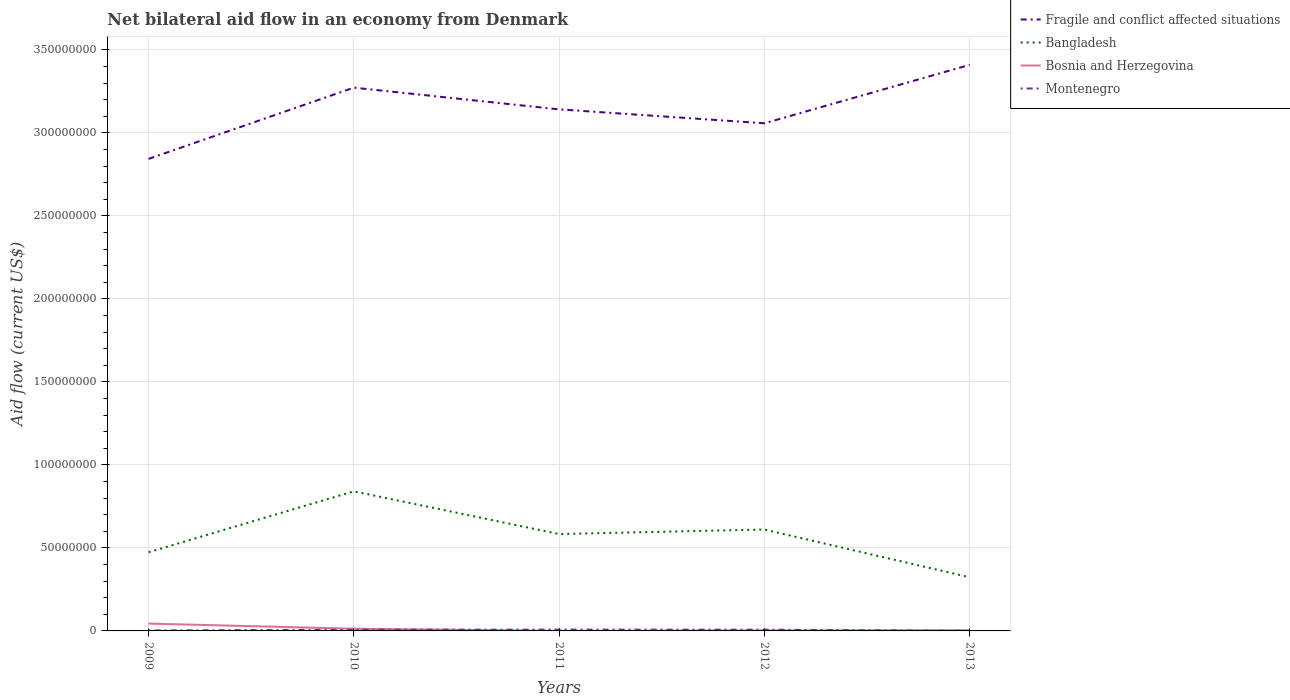How many different coloured lines are there?
Give a very brief answer. 4. Across all years, what is the maximum net bilateral aid flow in Bangladesh?
Your response must be concise. 3.23e+07. What is the total net bilateral aid flow in Bosnia and Herzegovina in the graph?
Provide a short and direct response. 4.13e+06. What is the difference between the highest and the second highest net bilateral aid flow in Montenegro?
Offer a terse response. 7.50e+05. How many lines are there?
Offer a very short reply. 4. What is the difference between two consecutive major ticks on the Y-axis?
Make the answer very short. 5.00e+07. How many legend labels are there?
Offer a terse response. 4. How are the legend labels stacked?
Provide a short and direct response. Vertical. What is the title of the graph?
Offer a terse response. Net bilateral aid flow in an economy from Denmark. What is the Aid flow (current US$) of Fragile and conflict affected situations in 2009?
Offer a terse response. 2.84e+08. What is the Aid flow (current US$) of Bangladesh in 2009?
Provide a succinct answer. 4.74e+07. What is the Aid flow (current US$) in Bosnia and Herzegovina in 2009?
Your response must be concise. 4.42e+06. What is the Aid flow (current US$) of Montenegro in 2009?
Make the answer very short. 2.90e+05. What is the Aid flow (current US$) in Fragile and conflict affected situations in 2010?
Make the answer very short. 3.27e+08. What is the Aid flow (current US$) in Bangladesh in 2010?
Your answer should be compact. 8.41e+07. What is the Aid flow (current US$) of Bosnia and Herzegovina in 2010?
Keep it short and to the point. 1.32e+06. What is the Aid flow (current US$) of Montenegro in 2010?
Offer a terse response. 7.10e+05. What is the Aid flow (current US$) of Fragile and conflict affected situations in 2011?
Your answer should be very brief. 3.14e+08. What is the Aid flow (current US$) of Bangladesh in 2011?
Offer a terse response. 5.84e+07. What is the Aid flow (current US$) of Montenegro in 2011?
Keep it short and to the point. 8.00e+05. What is the Aid flow (current US$) in Fragile and conflict affected situations in 2012?
Make the answer very short. 3.06e+08. What is the Aid flow (current US$) of Bangladesh in 2012?
Give a very brief answer. 6.11e+07. What is the Aid flow (current US$) of Montenegro in 2012?
Make the answer very short. 7.60e+05. What is the Aid flow (current US$) in Fragile and conflict affected situations in 2013?
Make the answer very short. 3.41e+08. What is the Aid flow (current US$) in Bangladesh in 2013?
Offer a terse response. 3.23e+07. What is the Aid flow (current US$) of Bosnia and Herzegovina in 2013?
Provide a succinct answer. 4.00e+05. What is the Aid flow (current US$) of Montenegro in 2013?
Offer a very short reply. 5.00e+04. Across all years, what is the maximum Aid flow (current US$) of Fragile and conflict affected situations?
Offer a very short reply. 3.41e+08. Across all years, what is the maximum Aid flow (current US$) of Bangladesh?
Your response must be concise. 8.41e+07. Across all years, what is the maximum Aid flow (current US$) in Bosnia and Herzegovina?
Keep it short and to the point. 4.42e+06. Across all years, what is the maximum Aid flow (current US$) in Montenegro?
Ensure brevity in your answer.  8.00e+05. Across all years, what is the minimum Aid flow (current US$) of Fragile and conflict affected situations?
Your answer should be very brief. 2.84e+08. Across all years, what is the minimum Aid flow (current US$) in Bangladesh?
Give a very brief answer. 3.23e+07. Across all years, what is the minimum Aid flow (current US$) in Bosnia and Herzegovina?
Provide a succinct answer. 6.00e+04. Across all years, what is the minimum Aid flow (current US$) of Montenegro?
Provide a succinct answer. 5.00e+04. What is the total Aid flow (current US$) in Fragile and conflict affected situations in the graph?
Ensure brevity in your answer.  1.57e+09. What is the total Aid flow (current US$) of Bangladesh in the graph?
Your response must be concise. 2.83e+08. What is the total Aid flow (current US$) in Bosnia and Herzegovina in the graph?
Your answer should be compact. 6.49e+06. What is the total Aid flow (current US$) of Montenegro in the graph?
Your answer should be compact. 2.61e+06. What is the difference between the Aid flow (current US$) of Fragile and conflict affected situations in 2009 and that in 2010?
Provide a succinct answer. -4.29e+07. What is the difference between the Aid flow (current US$) of Bangladesh in 2009 and that in 2010?
Offer a terse response. -3.67e+07. What is the difference between the Aid flow (current US$) of Bosnia and Herzegovina in 2009 and that in 2010?
Your answer should be very brief. 3.10e+06. What is the difference between the Aid flow (current US$) of Montenegro in 2009 and that in 2010?
Offer a terse response. -4.20e+05. What is the difference between the Aid flow (current US$) of Fragile and conflict affected situations in 2009 and that in 2011?
Keep it short and to the point. -2.98e+07. What is the difference between the Aid flow (current US$) in Bangladesh in 2009 and that in 2011?
Give a very brief answer. -1.10e+07. What is the difference between the Aid flow (current US$) of Bosnia and Herzegovina in 2009 and that in 2011?
Give a very brief answer. 4.36e+06. What is the difference between the Aid flow (current US$) in Montenegro in 2009 and that in 2011?
Your answer should be compact. -5.10e+05. What is the difference between the Aid flow (current US$) in Fragile and conflict affected situations in 2009 and that in 2012?
Ensure brevity in your answer.  -2.14e+07. What is the difference between the Aid flow (current US$) in Bangladesh in 2009 and that in 2012?
Keep it short and to the point. -1.37e+07. What is the difference between the Aid flow (current US$) of Bosnia and Herzegovina in 2009 and that in 2012?
Give a very brief answer. 4.13e+06. What is the difference between the Aid flow (current US$) of Montenegro in 2009 and that in 2012?
Your answer should be very brief. -4.70e+05. What is the difference between the Aid flow (current US$) of Fragile and conflict affected situations in 2009 and that in 2013?
Offer a very short reply. -5.66e+07. What is the difference between the Aid flow (current US$) of Bangladesh in 2009 and that in 2013?
Provide a succinct answer. 1.51e+07. What is the difference between the Aid flow (current US$) in Bosnia and Herzegovina in 2009 and that in 2013?
Provide a short and direct response. 4.02e+06. What is the difference between the Aid flow (current US$) in Fragile and conflict affected situations in 2010 and that in 2011?
Make the answer very short. 1.31e+07. What is the difference between the Aid flow (current US$) in Bangladesh in 2010 and that in 2011?
Keep it short and to the point. 2.57e+07. What is the difference between the Aid flow (current US$) of Bosnia and Herzegovina in 2010 and that in 2011?
Offer a very short reply. 1.26e+06. What is the difference between the Aid flow (current US$) in Fragile and conflict affected situations in 2010 and that in 2012?
Give a very brief answer. 2.15e+07. What is the difference between the Aid flow (current US$) in Bangladesh in 2010 and that in 2012?
Give a very brief answer. 2.30e+07. What is the difference between the Aid flow (current US$) of Bosnia and Herzegovina in 2010 and that in 2012?
Provide a short and direct response. 1.03e+06. What is the difference between the Aid flow (current US$) in Fragile and conflict affected situations in 2010 and that in 2013?
Give a very brief answer. -1.37e+07. What is the difference between the Aid flow (current US$) in Bangladesh in 2010 and that in 2013?
Offer a very short reply. 5.18e+07. What is the difference between the Aid flow (current US$) of Bosnia and Herzegovina in 2010 and that in 2013?
Ensure brevity in your answer.  9.20e+05. What is the difference between the Aid flow (current US$) of Fragile and conflict affected situations in 2011 and that in 2012?
Give a very brief answer. 8.39e+06. What is the difference between the Aid flow (current US$) in Bangladesh in 2011 and that in 2012?
Ensure brevity in your answer.  -2.73e+06. What is the difference between the Aid flow (current US$) in Bosnia and Herzegovina in 2011 and that in 2012?
Ensure brevity in your answer.  -2.30e+05. What is the difference between the Aid flow (current US$) in Fragile and conflict affected situations in 2011 and that in 2013?
Make the answer very short. -2.68e+07. What is the difference between the Aid flow (current US$) in Bangladesh in 2011 and that in 2013?
Your response must be concise. 2.60e+07. What is the difference between the Aid flow (current US$) in Montenegro in 2011 and that in 2013?
Make the answer very short. 7.50e+05. What is the difference between the Aid flow (current US$) of Fragile and conflict affected situations in 2012 and that in 2013?
Give a very brief answer. -3.52e+07. What is the difference between the Aid flow (current US$) of Bangladesh in 2012 and that in 2013?
Make the answer very short. 2.88e+07. What is the difference between the Aid flow (current US$) of Bosnia and Herzegovina in 2012 and that in 2013?
Provide a short and direct response. -1.10e+05. What is the difference between the Aid flow (current US$) in Montenegro in 2012 and that in 2013?
Provide a short and direct response. 7.10e+05. What is the difference between the Aid flow (current US$) in Fragile and conflict affected situations in 2009 and the Aid flow (current US$) in Bangladesh in 2010?
Offer a terse response. 2.00e+08. What is the difference between the Aid flow (current US$) of Fragile and conflict affected situations in 2009 and the Aid flow (current US$) of Bosnia and Herzegovina in 2010?
Provide a short and direct response. 2.83e+08. What is the difference between the Aid flow (current US$) in Fragile and conflict affected situations in 2009 and the Aid flow (current US$) in Montenegro in 2010?
Make the answer very short. 2.84e+08. What is the difference between the Aid flow (current US$) in Bangladesh in 2009 and the Aid flow (current US$) in Bosnia and Herzegovina in 2010?
Your answer should be compact. 4.61e+07. What is the difference between the Aid flow (current US$) in Bangladesh in 2009 and the Aid flow (current US$) in Montenegro in 2010?
Make the answer very short. 4.67e+07. What is the difference between the Aid flow (current US$) in Bosnia and Herzegovina in 2009 and the Aid flow (current US$) in Montenegro in 2010?
Provide a short and direct response. 3.71e+06. What is the difference between the Aid flow (current US$) in Fragile and conflict affected situations in 2009 and the Aid flow (current US$) in Bangladesh in 2011?
Ensure brevity in your answer.  2.26e+08. What is the difference between the Aid flow (current US$) of Fragile and conflict affected situations in 2009 and the Aid flow (current US$) of Bosnia and Herzegovina in 2011?
Offer a terse response. 2.84e+08. What is the difference between the Aid flow (current US$) in Fragile and conflict affected situations in 2009 and the Aid flow (current US$) in Montenegro in 2011?
Offer a very short reply. 2.84e+08. What is the difference between the Aid flow (current US$) of Bangladesh in 2009 and the Aid flow (current US$) of Bosnia and Herzegovina in 2011?
Ensure brevity in your answer.  4.74e+07. What is the difference between the Aid flow (current US$) of Bangladesh in 2009 and the Aid flow (current US$) of Montenegro in 2011?
Provide a short and direct response. 4.66e+07. What is the difference between the Aid flow (current US$) of Bosnia and Herzegovina in 2009 and the Aid flow (current US$) of Montenegro in 2011?
Ensure brevity in your answer.  3.62e+06. What is the difference between the Aid flow (current US$) in Fragile and conflict affected situations in 2009 and the Aid flow (current US$) in Bangladesh in 2012?
Keep it short and to the point. 2.23e+08. What is the difference between the Aid flow (current US$) in Fragile and conflict affected situations in 2009 and the Aid flow (current US$) in Bosnia and Herzegovina in 2012?
Your answer should be very brief. 2.84e+08. What is the difference between the Aid flow (current US$) of Fragile and conflict affected situations in 2009 and the Aid flow (current US$) of Montenegro in 2012?
Your response must be concise. 2.84e+08. What is the difference between the Aid flow (current US$) in Bangladesh in 2009 and the Aid flow (current US$) in Bosnia and Herzegovina in 2012?
Make the answer very short. 4.71e+07. What is the difference between the Aid flow (current US$) of Bangladesh in 2009 and the Aid flow (current US$) of Montenegro in 2012?
Ensure brevity in your answer.  4.66e+07. What is the difference between the Aid flow (current US$) in Bosnia and Herzegovina in 2009 and the Aid flow (current US$) in Montenegro in 2012?
Provide a succinct answer. 3.66e+06. What is the difference between the Aid flow (current US$) in Fragile and conflict affected situations in 2009 and the Aid flow (current US$) in Bangladesh in 2013?
Make the answer very short. 2.52e+08. What is the difference between the Aid flow (current US$) in Fragile and conflict affected situations in 2009 and the Aid flow (current US$) in Bosnia and Herzegovina in 2013?
Your answer should be compact. 2.84e+08. What is the difference between the Aid flow (current US$) in Fragile and conflict affected situations in 2009 and the Aid flow (current US$) in Montenegro in 2013?
Make the answer very short. 2.84e+08. What is the difference between the Aid flow (current US$) in Bangladesh in 2009 and the Aid flow (current US$) in Bosnia and Herzegovina in 2013?
Your response must be concise. 4.70e+07. What is the difference between the Aid flow (current US$) in Bangladesh in 2009 and the Aid flow (current US$) in Montenegro in 2013?
Offer a very short reply. 4.74e+07. What is the difference between the Aid flow (current US$) of Bosnia and Herzegovina in 2009 and the Aid flow (current US$) of Montenegro in 2013?
Your answer should be very brief. 4.37e+06. What is the difference between the Aid flow (current US$) of Fragile and conflict affected situations in 2010 and the Aid flow (current US$) of Bangladesh in 2011?
Keep it short and to the point. 2.69e+08. What is the difference between the Aid flow (current US$) of Fragile and conflict affected situations in 2010 and the Aid flow (current US$) of Bosnia and Herzegovina in 2011?
Provide a short and direct response. 3.27e+08. What is the difference between the Aid flow (current US$) of Fragile and conflict affected situations in 2010 and the Aid flow (current US$) of Montenegro in 2011?
Ensure brevity in your answer.  3.26e+08. What is the difference between the Aid flow (current US$) of Bangladesh in 2010 and the Aid flow (current US$) of Bosnia and Herzegovina in 2011?
Your answer should be compact. 8.40e+07. What is the difference between the Aid flow (current US$) of Bangladesh in 2010 and the Aid flow (current US$) of Montenegro in 2011?
Provide a succinct answer. 8.33e+07. What is the difference between the Aid flow (current US$) of Bosnia and Herzegovina in 2010 and the Aid flow (current US$) of Montenegro in 2011?
Offer a very short reply. 5.20e+05. What is the difference between the Aid flow (current US$) of Fragile and conflict affected situations in 2010 and the Aid flow (current US$) of Bangladesh in 2012?
Your response must be concise. 2.66e+08. What is the difference between the Aid flow (current US$) of Fragile and conflict affected situations in 2010 and the Aid flow (current US$) of Bosnia and Herzegovina in 2012?
Keep it short and to the point. 3.27e+08. What is the difference between the Aid flow (current US$) in Fragile and conflict affected situations in 2010 and the Aid flow (current US$) in Montenegro in 2012?
Provide a succinct answer. 3.27e+08. What is the difference between the Aid flow (current US$) in Bangladesh in 2010 and the Aid flow (current US$) in Bosnia and Herzegovina in 2012?
Your answer should be very brief. 8.38e+07. What is the difference between the Aid flow (current US$) in Bangladesh in 2010 and the Aid flow (current US$) in Montenegro in 2012?
Give a very brief answer. 8.33e+07. What is the difference between the Aid flow (current US$) of Bosnia and Herzegovina in 2010 and the Aid flow (current US$) of Montenegro in 2012?
Offer a terse response. 5.60e+05. What is the difference between the Aid flow (current US$) of Fragile and conflict affected situations in 2010 and the Aid flow (current US$) of Bangladesh in 2013?
Keep it short and to the point. 2.95e+08. What is the difference between the Aid flow (current US$) in Fragile and conflict affected situations in 2010 and the Aid flow (current US$) in Bosnia and Herzegovina in 2013?
Offer a very short reply. 3.27e+08. What is the difference between the Aid flow (current US$) in Fragile and conflict affected situations in 2010 and the Aid flow (current US$) in Montenegro in 2013?
Offer a terse response. 3.27e+08. What is the difference between the Aid flow (current US$) of Bangladesh in 2010 and the Aid flow (current US$) of Bosnia and Herzegovina in 2013?
Provide a succinct answer. 8.37e+07. What is the difference between the Aid flow (current US$) of Bangladesh in 2010 and the Aid flow (current US$) of Montenegro in 2013?
Keep it short and to the point. 8.40e+07. What is the difference between the Aid flow (current US$) of Bosnia and Herzegovina in 2010 and the Aid flow (current US$) of Montenegro in 2013?
Offer a terse response. 1.27e+06. What is the difference between the Aid flow (current US$) of Fragile and conflict affected situations in 2011 and the Aid flow (current US$) of Bangladesh in 2012?
Your response must be concise. 2.53e+08. What is the difference between the Aid flow (current US$) of Fragile and conflict affected situations in 2011 and the Aid flow (current US$) of Bosnia and Herzegovina in 2012?
Keep it short and to the point. 3.14e+08. What is the difference between the Aid flow (current US$) in Fragile and conflict affected situations in 2011 and the Aid flow (current US$) in Montenegro in 2012?
Make the answer very short. 3.13e+08. What is the difference between the Aid flow (current US$) in Bangladesh in 2011 and the Aid flow (current US$) in Bosnia and Herzegovina in 2012?
Your answer should be compact. 5.81e+07. What is the difference between the Aid flow (current US$) of Bangladesh in 2011 and the Aid flow (current US$) of Montenegro in 2012?
Offer a terse response. 5.76e+07. What is the difference between the Aid flow (current US$) of Bosnia and Herzegovina in 2011 and the Aid flow (current US$) of Montenegro in 2012?
Give a very brief answer. -7.00e+05. What is the difference between the Aid flow (current US$) in Fragile and conflict affected situations in 2011 and the Aid flow (current US$) in Bangladesh in 2013?
Ensure brevity in your answer.  2.82e+08. What is the difference between the Aid flow (current US$) of Fragile and conflict affected situations in 2011 and the Aid flow (current US$) of Bosnia and Herzegovina in 2013?
Make the answer very short. 3.14e+08. What is the difference between the Aid flow (current US$) in Fragile and conflict affected situations in 2011 and the Aid flow (current US$) in Montenegro in 2013?
Provide a short and direct response. 3.14e+08. What is the difference between the Aid flow (current US$) of Bangladesh in 2011 and the Aid flow (current US$) of Bosnia and Herzegovina in 2013?
Ensure brevity in your answer.  5.80e+07. What is the difference between the Aid flow (current US$) of Bangladesh in 2011 and the Aid flow (current US$) of Montenegro in 2013?
Your response must be concise. 5.83e+07. What is the difference between the Aid flow (current US$) of Bosnia and Herzegovina in 2011 and the Aid flow (current US$) of Montenegro in 2013?
Provide a succinct answer. 10000. What is the difference between the Aid flow (current US$) of Fragile and conflict affected situations in 2012 and the Aid flow (current US$) of Bangladesh in 2013?
Offer a very short reply. 2.73e+08. What is the difference between the Aid flow (current US$) in Fragile and conflict affected situations in 2012 and the Aid flow (current US$) in Bosnia and Herzegovina in 2013?
Keep it short and to the point. 3.05e+08. What is the difference between the Aid flow (current US$) in Fragile and conflict affected situations in 2012 and the Aid flow (current US$) in Montenegro in 2013?
Provide a short and direct response. 3.06e+08. What is the difference between the Aid flow (current US$) in Bangladesh in 2012 and the Aid flow (current US$) in Bosnia and Herzegovina in 2013?
Give a very brief answer. 6.07e+07. What is the difference between the Aid flow (current US$) of Bangladesh in 2012 and the Aid flow (current US$) of Montenegro in 2013?
Ensure brevity in your answer.  6.10e+07. What is the difference between the Aid flow (current US$) of Bosnia and Herzegovina in 2012 and the Aid flow (current US$) of Montenegro in 2013?
Your answer should be very brief. 2.40e+05. What is the average Aid flow (current US$) of Fragile and conflict affected situations per year?
Provide a succinct answer. 3.15e+08. What is the average Aid flow (current US$) in Bangladesh per year?
Keep it short and to the point. 5.67e+07. What is the average Aid flow (current US$) in Bosnia and Herzegovina per year?
Your answer should be compact. 1.30e+06. What is the average Aid flow (current US$) in Montenegro per year?
Offer a very short reply. 5.22e+05. In the year 2009, what is the difference between the Aid flow (current US$) in Fragile and conflict affected situations and Aid flow (current US$) in Bangladesh?
Give a very brief answer. 2.37e+08. In the year 2009, what is the difference between the Aid flow (current US$) of Fragile and conflict affected situations and Aid flow (current US$) of Bosnia and Herzegovina?
Give a very brief answer. 2.80e+08. In the year 2009, what is the difference between the Aid flow (current US$) of Fragile and conflict affected situations and Aid flow (current US$) of Montenegro?
Your response must be concise. 2.84e+08. In the year 2009, what is the difference between the Aid flow (current US$) in Bangladesh and Aid flow (current US$) in Bosnia and Herzegovina?
Offer a very short reply. 4.30e+07. In the year 2009, what is the difference between the Aid flow (current US$) of Bangladesh and Aid flow (current US$) of Montenegro?
Your answer should be very brief. 4.71e+07. In the year 2009, what is the difference between the Aid flow (current US$) in Bosnia and Herzegovina and Aid flow (current US$) in Montenegro?
Your response must be concise. 4.13e+06. In the year 2010, what is the difference between the Aid flow (current US$) of Fragile and conflict affected situations and Aid flow (current US$) of Bangladesh?
Offer a terse response. 2.43e+08. In the year 2010, what is the difference between the Aid flow (current US$) of Fragile and conflict affected situations and Aid flow (current US$) of Bosnia and Herzegovina?
Ensure brevity in your answer.  3.26e+08. In the year 2010, what is the difference between the Aid flow (current US$) of Fragile and conflict affected situations and Aid flow (current US$) of Montenegro?
Give a very brief answer. 3.27e+08. In the year 2010, what is the difference between the Aid flow (current US$) in Bangladesh and Aid flow (current US$) in Bosnia and Herzegovina?
Your response must be concise. 8.28e+07. In the year 2010, what is the difference between the Aid flow (current US$) in Bangladesh and Aid flow (current US$) in Montenegro?
Offer a very short reply. 8.34e+07. In the year 2011, what is the difference between the Aid flow (current US$) of Fragile and conflict affected situations and Aid flow (current US$) of Bangladesh?
Keep it short and to the point. 2.56e+08. In the year 2011, what is the difference between the Aid flow (current US$) in Fragile and conflict affected situations and Aid flow (current US$) in Bosnia and Herzegovina?
Keep it short and to the point. 3.14e+08. In the year 2011, what is the difference between the Aid flow (current US$) of Fragile and conflict affected situations and Aid flow (current US$) of Montenegro?
Ensure brevity in your answer.  3.13e+08. In the year 2011, what is the difference between the Aid flow (current US$) in Bangladesh and Aid flow (current US$) in Bosnia and Herzegovina?
Keep it short and to the point. 5.83e+07. In the year 2011, what is the difference between the Aid flow (current US$) in Bangladesh and Aid flow (current US$) in Montenegro?
Your answer should be very brief. 5.76e+07. In the year 2011, what is the difference between the Aid flow (current US$) in Bosnia and Herzegovina and Aid flow (current US$) in Montenegro?
Ensure brevity in your answer.  -7.40e+05. In the year 2012, what is the difference between the Aid flow (current US$) in Fragile and conflict affected situations and Aid flow (current US$) in Bangladesh?
Ensure brevity in your answer.  2.45e+08. In the year 2012, what is the difference between the Aid flow (current US$) of Fragile and conflict affected situations and Aid flow (current US$) of Bosnia and Herzegovina?
Make the answer very short. 3.06e+08. In the year 2012, what is the difference between the Aid flow (current US$) of Fragile and conflict affected situations and Aid flow (current US$) of Montenegro?
Provide a succinct answer. 3.05e+08. In the year 2012, what is the difference between the Aid flow (current US$) of Bangladesh and Aid flow (current US$) of Bosnia and Herzegovina?
Offer a terse response. 6.08e+07. In the year 2012, what is the difference between the Aid flow (current US$) in Bangladesh and Aid flow (current US$) in Montenegro?
Provide a succinct answer. 6.03e+07. In the year 2012, what is the difference between the Aid flow (current US$) of Bosnia and Herzegovina and Aid flow (current US$) of Montenegro?
Your answer should be very brief. -4.70e+05. In the year 2013, what is the difference between the Aid flow (current US$) in Fragile and conflict affected situations and Aid flow (current US$) in Bangladesh?
Ensure brevity in your answer.  3.09e+08. In the year 2013, what is the difference between the Aid flow (current US$) in Fragile and conflict affected situations and Aid flow (current US$) in Bosnia and Herzegovina?
Provide a succinct answer. 3.41e+08. In the year 2013, what is the difference between the Aid flow (current US$) of Fragile and conflict affected situations and Aid flow (current US$) of Montenegro?
Make the answer very short. 3.41e+08. In the year 2013, what is the difference between the Aid flow (current US$) of Bangladesh and Aid flow (current US$) of Bosnia and Herzegovina?
Ensure brevity in your answer.  3.19e+07. In the year 2013, what is the difference between the Aid flow (current US$) in Bangladesh and Aid flow (current US$) in Montenegro?
Give a very brief answer. 3.23e+07. In the year 2013, what is the difference between the Aid flow (current US$) of Bosnia and Herzegovina and Aid flow (current US$) of Montenegro?
Provide a short and direct response. 3.50e+05. What is the ratio of the Aid flow (current US$) in Fragile and conflict affected situations in 2009 to that in 2010?
Your answer should be compact. 0.87. What is the ratio of the Aid flow (current US$) in Bangladesh in 2009 to that in 2010?
Provide a short and direct response. 0.56. What is the ratio of the Aid flow (current US$) of Bosnia and Herzegovina in 2009 to that in 2010?
Your response must be concise. 3.35. What is the ratio of the Aid flow (current US$) of Montenegro in 2009 to that in 2010?
Offer a very short reply. 0.41. What is the ratio of the Aid flow (current US$) in Fragile and conflict affected situations in 2009 to that in 2011?
Your answer should be compact. 0.91. What is the ratio of the Aid flow (current US$) of Bangladesh in 2009 to that in 2011?
Offer a very short reply. 0.81. What is the ratio of the Aid flow (current US$) in Bosnia and Herzegovina in 2009 to that in 2011?
Your answer should be compact. 73.67. What is the ratio of the Aid flow (current US$) of Montenegro in 2009 to that in 2011?
Give a very brief answer. 0.36. What is the ratio of the Aid flow (current US$) of Fragile and conflict affected situations in 2009 to that in 2012?
Your response must be concise. 0.93. What is the ratio of the Aid flow (current US$) of Bangladesh in 2009 to that in 2012?
Provide a succinct answer. 0.78. What is the ratio of the Aid flow (current US$) in Bosnia and Herzegovina in 2009 to that in 2012?
Give a very brief answer. 15.24. What is the ratio of the Aid flow (current US$) in Montenegro in 2009 to that in 2012?
Offer a terse response. 0.38. What is the ratio of the Aid flow (current US$) of Fragile and conflict affected situations in 2009 to that in 2013?
Your response must be concise. 0.83. What is the ratio of the Aid flow (current US$) in Bangladesh in 2009 to that in 2013?
Your response must be concise. 1.47. What is the ratio of the Aid flow (current US$) in Bosnia and Herzegovina in 2009 to that in 2013?
Provide a succinct answer. 11.05. What is the ratio of the Aid flow (current US$) of Montenegro in 2009 to that in 2013?
Offer a very short reply. 5.8. What is the ratio of the Aid flow (current US$) of Fragile and conflict affected situations in 2010 to that in 2011?
Your answer should be very brief. 1.04. What is the ratio of the Aid flow (current US$) in Bangladesh in 2010 to that in 2011?
Ensure brevity in your answer.  1.44. What is the ratio of the Aid flow (current US$) in Bosnia and Herzegovina in 2010 to that in 2011?
Offer a very short reply. 22. What is the ratio of the Aid flow (current US$) in Montenegro in 2010 to that in 2011?
Provide a succinct answer. 0.89. What is the ratio of the Aid flow (current US$) of Fragile and conflict affected situations in 2010 to that in 2012?
Provide a short and direct response. 1.07. What is the ratio of the Aid flow (current US$) of Bangladesh in 2010 to that in 2012?
Offer a terse response. 1.38. What is the ratio of the Aid flow (current US$) of Bosnia and Herzegovina in 2010 to that in 2012?
Offer a terse response. 4.55. What is the ratio of the Aid flow (current US$) in Montenegro in 2010 to that in 2012?
Give a very brief answer. 0.93. What is the ratio of the Aid flow (current US$) of Fragile and conflict affected situations in 2010 to that in 2013?
Offer a very short reply. 0.96. What is the ratio of the Aid flow (current US$) of Bangladesh in 2010 to that in 2013?
Offer a terse response. 2.6. What is the ratio of the Aid flow (current US$) of Fragile and conflict affected situations in 2011 to that in 2012?
Your answer should be very brief. 1.03. What is the ratio of the Aid flow (current US$) in Bangladesh in 2011 to that in 2012?
Keep it short and to the point. 0.96. What is the ratio of the Aid flow (current US$) of Bosnia and Herzegovina in 2011 to that in 2012?
Make the answer very short. 0.21. What is the ratio of the Aid flow (current US$) in Montenegro in 2011 to that in 2012?
Your answer should be compact. 1.05. What is the ratio of the Aid flow (current US$) of Fragile and conflict affected situations in 2011 to that in 2013?
Offer a terse response. 0.92. What is the ratio of the Aid flow (current US$) in Bangladesh in 2011 to that in 2013?
Offer a very short reply. 1.81. What is the ratio of the Aid flow (current US$) in Bosnia and Herzegovina in 2011 to that in 2013?
Your answer should be compact. 0.15. What is the ratio of the Aid flow (current US$) in Montenegro in 2011 to that in 2013?
Provide a short and direct response. 16. What is the ratio of the Aid flow (current US$) in Fragile and conflict affected situations in 2012 to that in 2013?
Provide a succinct answer. 0.9. What is the ratio of the Aid flow (current US$) of Bangladesh in 2012 to that in 2013?
Keep it short and to the point. 1.89. What is the ratio of the Aid flow (current US$) in Bosnia and Herzegovina in 2012 to that in 2013?
Provide a short and direct response. 0.72. What is the difference between the highest and the second highest Aid flow (current US$) of Fragile and conflict affected situations?
Give a very brief answer. 1.37e+07. What is the difference between the highest and the second highest Aid flow (current US$) of Bangladesh?
Provide a succinct answer. 2.30e+07. What is the difference between the highest and the second highest Aid flow (current US$) in Bosnia and Herzegovina?
Your response must be concise. 3.10e+06. What is the difference between the highest and the lowest Aid flow (current US$) of Fragile and conflict affected situations?
Your response must be concise. 5.66e+07. What is the difference between the highest and the lowest Aid flow (current US$) of Bangladesh?
Your answer should be compact. 5.18e+07. What is the difference between the highest and the lowest Aid flow (current US$) of Bosnia and Herzegovina?
Make the answer very short. 4.36e+06. What is the difference between the highest and the lowest Aid flow (current US$) of Montenegro?
Provide a short and direct response. 7.50e+05. 